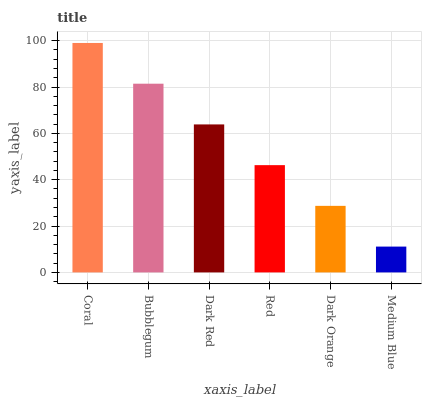Is Medium Blue the minimum?
Answer yes or no. Yes. Is Coral the maximum?
Answer yes or no. Yes. Is Bubblegum the minimum?
Answer yes or no. No. Is Bubblegum the maximum?
Answer yes or no. No. Is Coral greater than Bubblegum?
Answer yes or no. Yes. Is Bubblegum less than Coral?
Answer yes or no. Yes. Is Bubblegum greater than Coral?
Answer yes or no. No. Is Coral less than Bubblegum?
Answer yes or no. No. Is Dark Red the high median?
Answer yes or no. Yes. Is Red the low median?
Answer yes or no. Yes. Is Bubblegum the high median?
Answer yes or no. No. Is Bubblegum the low median?
Answer yes or no. No. 